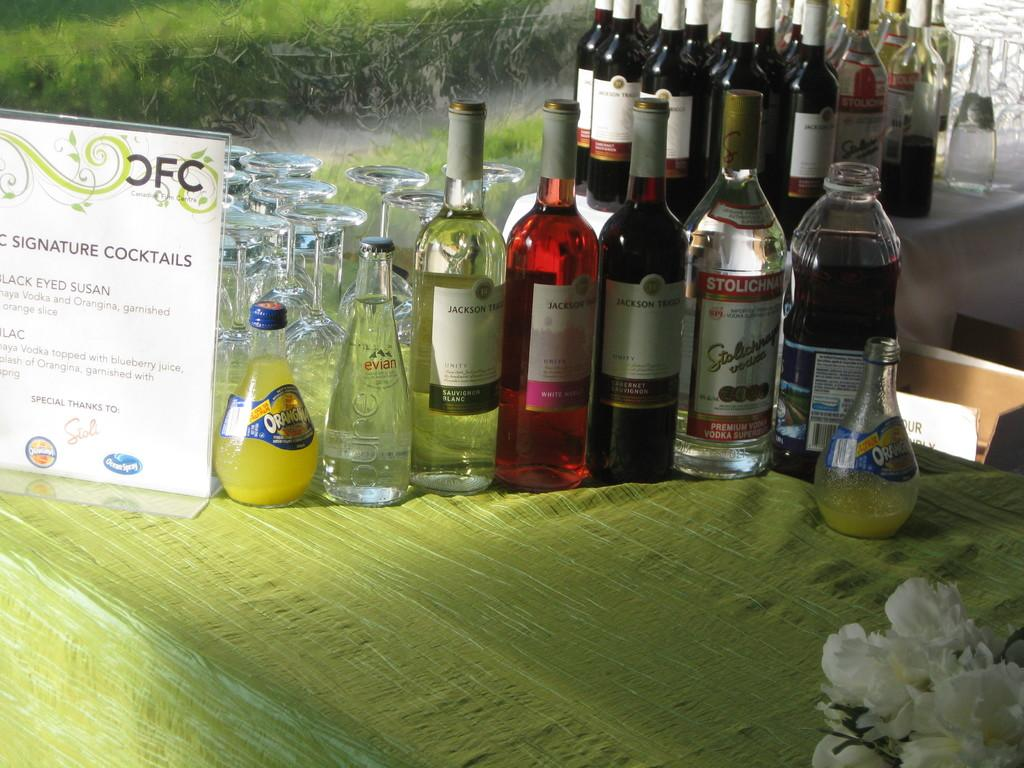<image>
Share a concise interpretation of the image provided. A bar is set up with bottles and a sign that says signature cocktails. 